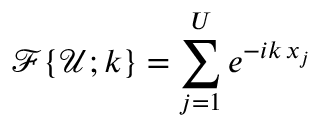<formula> <loc_0><loc_0><loc_500><loc_500>\mathcal { F } \{ \mathcal { U } ; k \} = \sum _ { j = 1 } ^ { U } e ^ { - i k \, x _ { j } }</formula> 